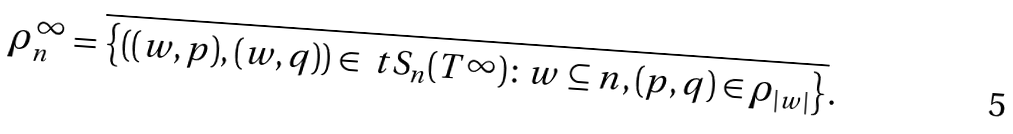<formula> <loc_0><loc_0><loc_500><loc_500>\rho ^ { \infty } _ { n } & = \overline { \left \{ ( ( w , p ) , ( w , q ) ) \in \ t S _ { n } ( T ^ { \infty } ) \colon w \subseteq n , ( p , q ) \in \rho _ { | w | } \right \} } .</formula> 